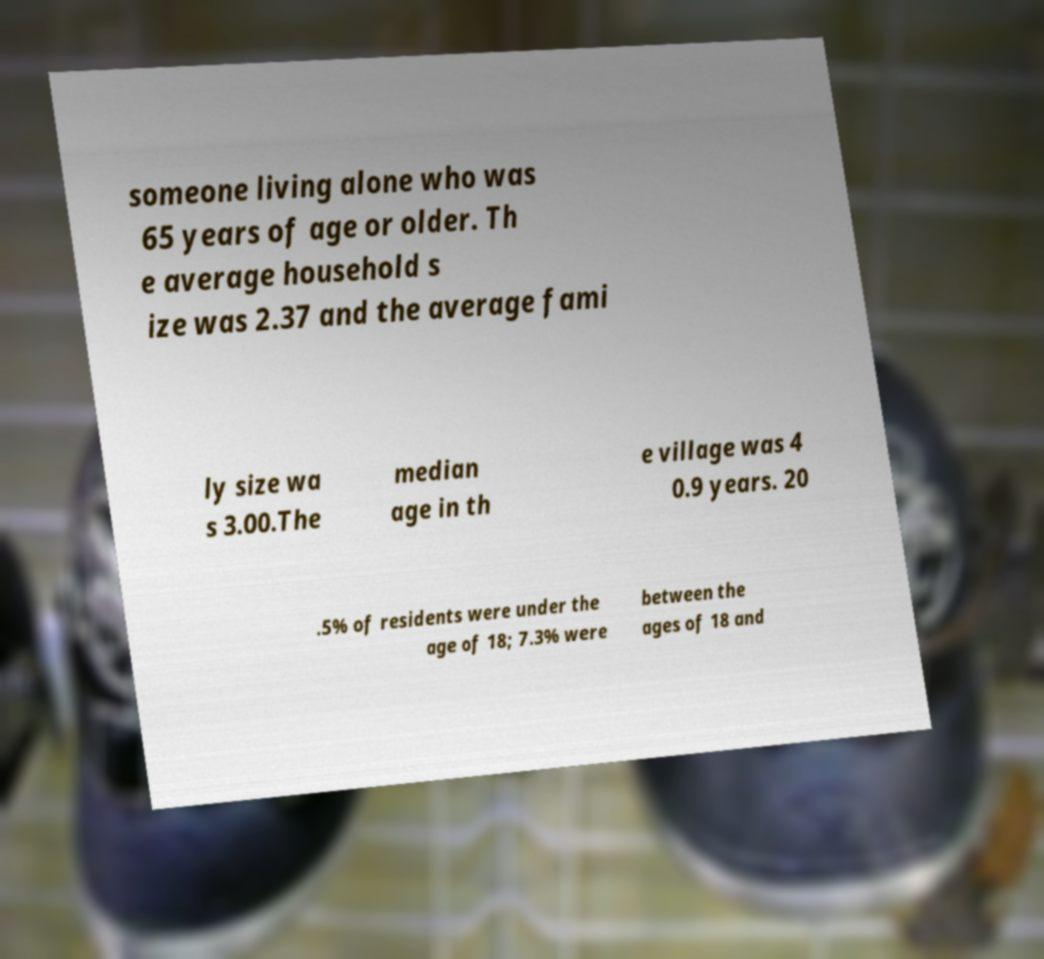Please read and relay the text visible in this image. What does it say? someone living alone who was 65 years of age or older. Th e average household s ize was 2.37 and the average fami ly size wa s 3.00.The median age in th e village was 4 0.9 years. 20 .5% of residents were under the age of 18; 7.3% were between the ages of 18 and 